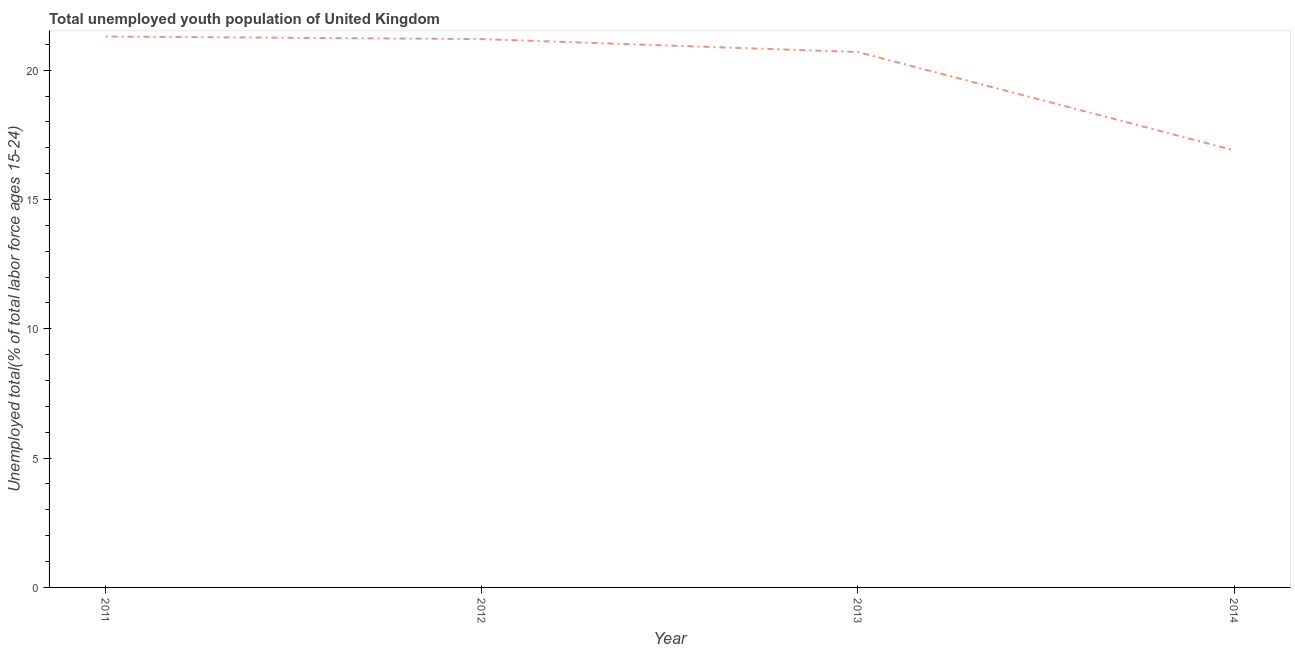What is the unemployed youth in 2012?
Give a very brief answer. 21.2. Across all years, what is the maximum unemployed youth?
Ensure brevity in your answer.  21.3. Across all years, what is the minimum unemployed youth?
Ensure brevity in your answer.  16.9. In which year was the unemployed youth maximum?
Give a very brief answer. 2011. In which year was the unemployed youth minimum?
Offer a very short reply. 2014. What is the sum of the unemployed youth?
Your response must be concise. 80.1. What is the difference between the unemployed youth in 2012 and 2014?
Your answer should be compact. 4.3. What is the average unemployed youth per year?
Offer a very short reply. 20.03. What is the median unemployed youth?
Your response must be concise. 20.95. In how many years, is the unemployed youth greater than 17 %?
Give a very brief answer. 3. Do a majority of the years between 2013 and 2011 (inclusive) have unemployed youth greater than 5 %?
Give a very brief answer. No. What is the ratio of the unemployed youth in 2011 to that in 2013?
Offer a terse response. 1.03. What is the difference between the highest and the second highest unemployed youth?
Provide a short and direct response. 0.1. Is the sum of the unemployed youth in 2011 and 2012 greater than the maximum unemployed youth across all years?
Your response must be concise. Yes. What is the difference between the highest and the lowest unemployed youth?
Keep it short and to the point. 4.4. In how many years, is the unemployed youth greater than the average unemployed youth taken over all years?
Provide a short and direct response. 3. Does the unemployed youth monotonically increase over the years?
Provide a short and direct response. No. How many lines are there?
Provide a succinct answer. 1. How many years are there in the graph?
Your answer should be very brief. 4. Are the values on the major ticks of Y-axis written in scientific E-notation?
Keep it short and to the point. No. Does the graph contain any zero values?
Keep it short and to the point. No. What is the title of the graph?
Provide a short and direct response. Total unemployed youth population of United Kingdom. What is the label or title of the X-axis?
Provide a short and direct response. Year. What is the label or title of the Y-axis?
Make the answer very short. Unemployed total(% of total labor force ages 15-24). What is the Unemployed total(% of total labor force ages 15-24) in 2011?
Provide a short and direct response. 21.3. What is the Unemployed total(% of total labor force ages 15-24) of 2012?
Offer a terse response. 21.2. What is the Unemployed total(% of total labor force ages 15-24) in 2013?
Keep it short and to the point. 20.7. What is the Unemployed total(% of total labor force ages 15-24) in 2014?
Offer a terse response. 16.9. What is the difference between the Unemployed total(% of total labor force ages 15-24) in 2011 and 2012?
Offer a terse response. 0.1. What is the difference between the Unemployed total(% of total labor force ages 15-24) in 2011 and 2013?
Give a very brief answer. 0.6. What is the difference between the Unemployed total(% of total labor force ages 15-24) in 2011 and 2014?
Ensure brevity in your answer.  4.4. What is the ratio of the Unemployed total(% of total labor force ages 15-24) in 2011 to that in 2013?
Provide a short and direct response. 1.03. What is the ratio of the Unemployed total(% of total labor force ages 15-24) in 2011 to that in 2014?
Ensure brevity in your answer.  1.26. What is the ratio of the Unemployed total(% of total labor force ages 15-24) in 2012 to that in 2013?
Make the answer very short. 1.02. What is the ratio of the Unemployed total(% of total labor force ages 15-24) in 2012 to that in 2014?
Offer a very short reply. 1.25. What is the ratio of the Unemployed total(% of total labor force ages 15-24) in 2013 to that in 2014?
Offer a very short reply. 1.23. 